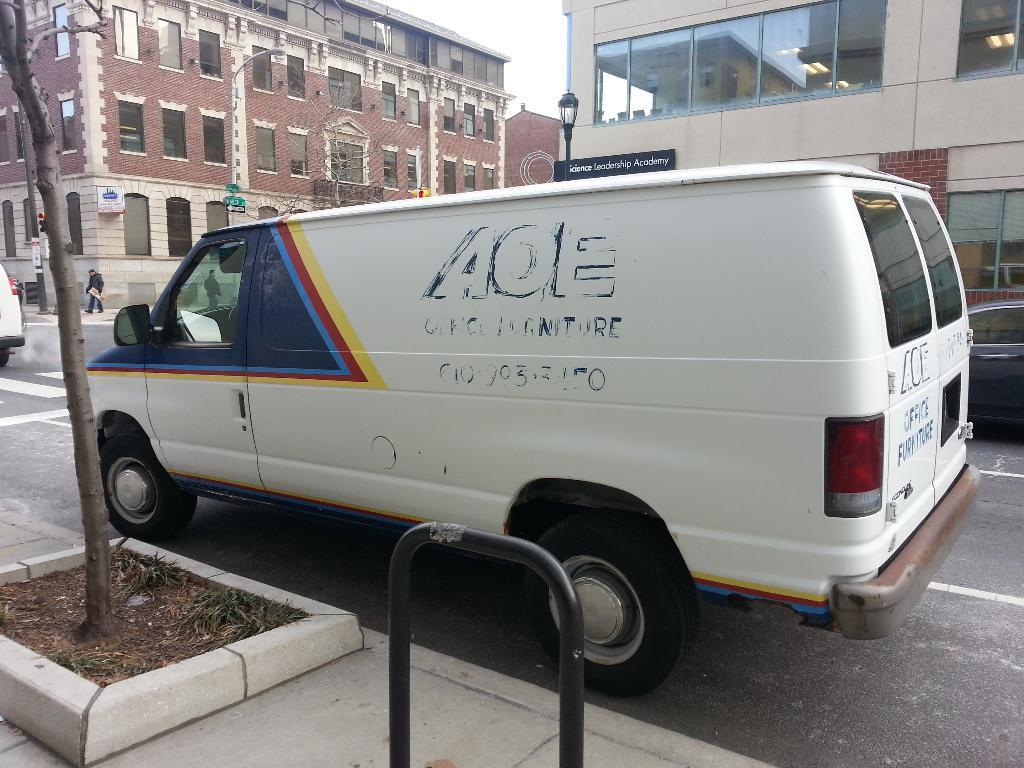Please provide a concise description of this image. In this picture I can see vehicles on the road, there are two persons, there are buildings, lights, boards, trees, and in the background there is sky. 